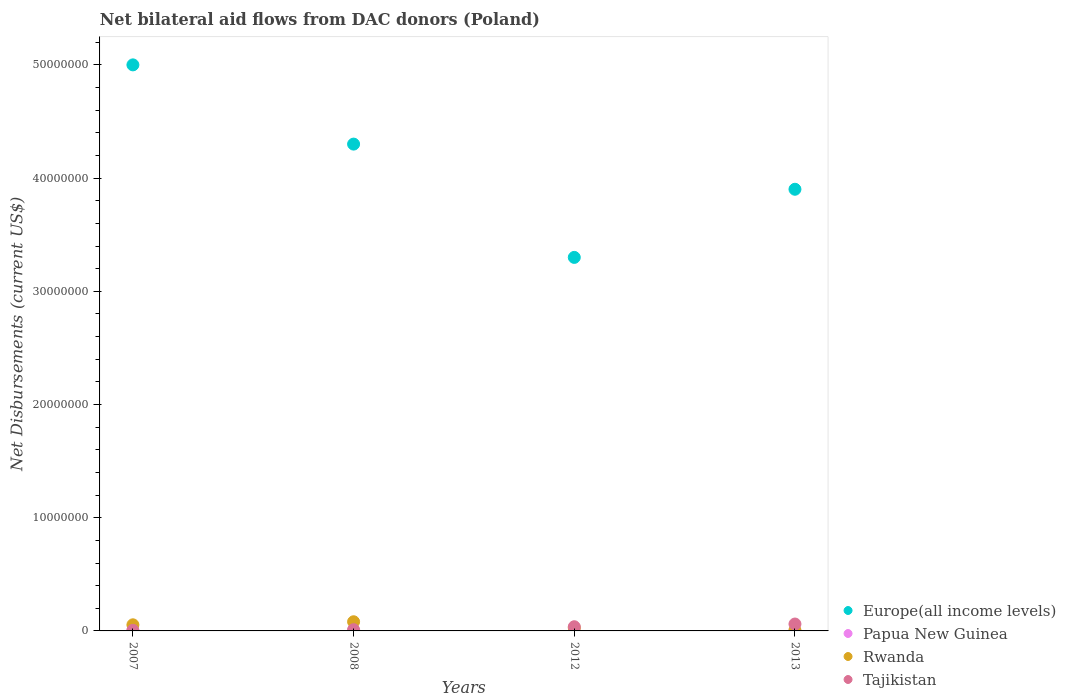How many different coloured dotlines are there?
Provide a succinct answer. 4. Is the number of dotlines equal to the number of legend labels?
Your answer should be compact. Yes. Across all years, what is the maximum net bilateral aid flows in Rwanda?
Provide a short and direct response. 8.10e+05. What is the total net bilateral aid flows in Europe(all income levels) in the graph?
Offer a very short reply. 1.65e+08. What is the average net bilateral aid flows in Papua New Guinea per year?
Give a very brief answer. 2.00e+04. In the year 2007, what is the difference between the net bilateral aid flows in Tajikistan and net bilateral aid flows in Europe(all income levels)?
Keep it short and to the point. -5.00e+07. In how many years, is the net bilateral aid flows in Rwanda greater than 28000000 US$?
Ensure brevity in your answer.  0. What is the ratio of the net bilateral aid flows in Tajikistan in 2008 to that in 2012?
Give a very brief answer. 0.3. Is the net bilateral aid flows in Papua New Guinea in 2008 less than that in 2013?
Offer a very short reply. Yes. What is the difference between the highest and the lowest net bilateral aid flows in Tajikistan?
Ensure brevity in your answer.  5.60e+05. In how many years, is the net bilateral aid flows in Papua New Guinea greater than the average net bilateral aid flows in Papua New Guinea taken over all years?
Your answer should be very brief. 1. Is the sum of the net bilateral aid flows in Rwanda in 2007 and 2013 greater than the maximum net bilateral aid flows in Tajikistan across all years?
Provide a short and direct response. No. Is it the case that in every year, the sum of the net bilateral aid flows in Papua New Guinea and net bilateral aid flows in Rwanda  is greater than the net bilateral aid flows in Europe(all income levels)?
Provide a succinct answer. No. Are the values on the major ticks of Y-axis written in scientific E-notation?
Your answer should be compact. No. Does the graph contain any zero values?
Ensure brevity in your answer.  No. Does the graph contain grids?
Ensure brevity in your answer.  No. What is the title of the graph?
Give a very brief answer. Net bilateral aid flows from DAC donors (Poland). What is the label or title of the X-axis?
Keep it short and to the point. Years. What is the label or title of the Y-axis?
Provide a short and direct response. Net Disbursements (current US$). What is the Net Disbursements (current US$) in Europe(all income levels) in 2007?
Your answer should be very brief. 5.00e+07. What is the Net Disbursements (current US$) of Papua New Guinea in 2007?
Offer a terse response. 3.00e+04. What is the Net Disbursements (current US$) of Rwanda in 2007?
Provide a succinct answer. 5.40e+05. What is the Net Disbursements (current US$) of Europe(all income levels) in 2008?
Provide a short and direct response. 4.30e+07. What is the Net Disbursements (current US$) in Papua New Guinea in 2008?
Provide a succinct answer. 10000. What is the Net Disbursements (current US$) in Rwanda in 2008?
Offer a very short reply. 8.10e+05. What is the Net Disbursements (current US$) of Tajikistan in 2008?
Your response must be concise. 1.10e+05. What is the Net Disbursements (current US$) in Europe(all income levels) in 2012?
Make the answer very short. 3.30e+07. What is the Net Disbursements (current US$) in Papua New Guinea in 2012?
Ensure brevity in your answer.  2.00e+04. What is the Net Disbursements (current US$) of Europe(all income levels) in 2013?
Your answer should be very brief. 3.90e+07. What is the Net Disbursements (current US$) of Rwanda in 2013?
Offer a very short reply. 5.00e+04. What is the Net Disbursements (current US$) of Tajikistan in 2013?
Give a very brief answer. 6.10e+05. Across all years, what is the maximum Net Disbursements (current US$) in Europe(all income levels)?
Provide a short and direct response. 5.00e+07. Across all years, what is the maximum Net Disbursements (current US$) of Rwanda?
Provide a short and direct response. 8.10e+05. Across all years, what is the minimum Net Disbursements (current US$) in Europe(all income levels)?
Ensure brevity in your answer.  3.30e+07. What is the total Net Disbursements (current US$) of Europe(all income levels) in the graph?
Your answer should be compact. 1.65e+08. What is the total Net Disbursements (current US$) in Papua New Guinea in the graph?
Provide a short and direct response. 8.00e+04. What is the total Net Disbursements (current US$) of Rwanda in the graph?
Your answer should be very brief. 1.67e+06. What is the total Net Disbursements (current US$) in Tajikistan in the graph?
Your answer should be very brief. 1.14e+06. What is the difference between the Net Disbursements (current US$) of Europe(all income levels) in 2007 and that in 2012?
Your answer should be very brief. 1.70e+07. What is the difference between the Net Disbursements (current US$) in Papua New Guinea in 2007 and that in 2012?
Give a very brief answer. 10000. What is the difference between the Net Disbursements (current US$) of Tajikistan in 2007 and that in 2012?
Your answer should be compact. -3.20e+05. What is the difference between the Net Disbursements (current US$) in Europe(all income levels) in 2007 and that in 2013?
Offer a terse response. 1.10e+07. What is the difference between the Net Disbursements (current US$) of Tajikistan in 2007 and that in 2013?
Provide a succinct answer. -5.60e+05. What is the difference between the Net Disbursements (current US$) of Europe(all income levels) in 2008 and that in 2012?
Provide a succinct answer. 1.00e+07. What is the difference between the Net Disbursements (current US$) in Rwanda in 2008 and that in 2012?
Keep it short and to the point. 5.40e+05. What is the difference between the Net Disbursements (current US$) in Tajikistan in 2008 and that in 2012?
Give a very brief answer. -2.60e+05. What is the difference between the Net Disbursements (current US$) of Europe(all income levels) in 2008 and that in 2013?
Keep it short and to the point. 3.99e+06. What is the difference between the Net Disbursements (current US$) in Rwanda in 2008 and that in 2013?
Make the answer very short. 7.60e+05. What is the difference between the Net Disbursements (current US$) in Tajikistan in 2008 and that in 2013?
Provide a succinct answer. -5.00e+05. What is the difference between the Net Disbursements (current US$) of Europe(all income levels) in 2012 and that in 2013?
Your answer should be very brief. -6.02e+06. What is the difference between the Net Disbursements (current US$) of Rwanda in 2012 and that in 2013?
Your answer should be very brief. 2.20e+05. What is the difference between the Net Disbursements (current US$) of Europe(all income levels) in 2007 and the Net Disbursements (current US$) of Papua New Guinea in 2008?
Offer a very short reply. 5.00e+07. What is the difference between the Net Disbursements (current US$) in Europe(all income levels) in 2007 and the Net Disbursements (current US$) in Rwanda in 2008?
Your answer should be compact. 4.92e+07. What is the difference between the Net Disbursements (current US$) of Europe(all income levels) in 2007 and the Net Disbursements (current US$) of Tajikistan in 2008?
Ensure brevity in your answer.  4.99e+07. What is the difference between the Net Disbursements (current US$) in Papua New Guinea in 2007 and the Net Disbursements (current US$) in Rwanda in 2008?
Provide a succinct answer. -7.80e+05. What is the difference between the Net Disbursements (current US$) of Papua New Guinea in 2007 and the Net Disbursements (current US$) of Tajikistan in 2008?
Provide a short and direct response. -8.00e+04. What is the difference between the Net Disbursements (current US$) in Europe(all income levels) in 2007 and the Net Disbursements (current US$) in Papua New Guinea in 2012?
Give a very brief answer. 5.00e+07. What is the difference between the Net Disbursements (current US$) in Europe(all income levels) in 2007 and the Net Disbursements (current US$) in Rwanda in 2012?
Provide a succinct answer. 4.97e+07. What is the difference between the Net Disbursements (current US$) of Europe(all income levels) in 2007 and the Net Disbursements (current US$) of Tajikistan in 2012?
Ensure brevity in your answer.  4.96e+07. What is the difference between the Net Disbursements (current US$) of Papua New Guinea in 2007 and the Net Disbursements (current US$) of Tajikistan in 2012?
Make the answer very short. -3.40e+05. What is the difference between the Net Disbursements (current US$) in Rwanda in 2007 and the Net Disbursements (current US$) in Tajikistan in 2012?
Provide a succinct answer. 1.70e+05. What is the difference between the Net Disbursements (current US$) of Europe(all income levels) in 2007 and the Net Disbursements (current US$) of Papua New Guinea in 2013?
Provide a succinct answer. 5.00e+07. What is the difference between the Net Disbursements (current US$) in Europe(all income levels) in 2007 and the Net Disbursements (current US$) in Rwanda in 2013?
Keep it short and to the point. 5.00e+07. What is the difference between the Net Disbursements (current US$) in Europe(all income levels) in 2007 and the Net Disbursements (current US$) in Tajikistan in 2013?
Provide a succinct answer. 4.94e+07. What is the difference between the Net Disbursements (current US$) of Papua New Guinea in 2007 and the Net Disbursements (current US$) of Rwanda in 2013?
Give a very brief answer. -2.00e+04. What is the difference between the Net Disbursements (current US$) in Papua New Guinea in 2007 and the Net Disbursements (current US$) in Tajikistan in 2013?
Provide a short and direct response. -5.80e+05. What is the difference between the Net Disbursements (current US$) of Rwanda in 2007 and the Net Disbursements (current US$) of Tajikistan in 2013?
Your answer should be very brief. -7.00e+04. What is the difference between the Net Disbursements (current US$) of Europe(all income levels) in 2008 and the Net Disbursements (current US$) of Papua New Guinea in 2012?
Ensure brevity in your answer.  4.30e+07. What is the difference between the Net Disbursements (current US$) of Europe(all income levels) in 2008 and the Net Disbursements (current US$) of Rwanda in 2012?
Provide a short and direct response. 4.27e+07. What is the difference between the Net Disbursements (current US$) in Europe(all income levels) in 2008 and the Net Disbursements (current US$) in Tajikistan in 2012?
Offer a terse response. 4.26e+07. What is the difference between the Net Disbursements (current US$) in Papua New Guinea in 2008 and the Net Disbursements (current US$) in Tajikistan in 2012?
Your answer should be very brief. -3.60e+05. What is the difference between the Net Disbursements (current US$) in Rwanda in 2008 and the Net Disbursements (current US$) in Tajikistan in 2012?
Your answer should be compact. 4.40e+05. What is the difference between the Net Disbursements (current US$) of Europe(all income levels) in 2008 and the Net Disbursements (current US$) of Papua New Guinea in 2013?
Keep it short and to the point. 4.30e+07. What is the difference between the Net Disbursements (current US$) in Europe(all income levels) in 2008 and the Net Disbursements (current US$) in Rwanda in 2013?
Offer a terse response. 4.30e+07. What is the difference between the Net Disbursements (current US$) in Europe(all income levels) in 2008 and the Net Disbursements (current US$) in Tajikistan in 2013?
Keep it short and to the point. 4.24e+07. What is the difference between the Net Disbursements (current US$) of Papua New Guinea in 2008 and the Net Disbursements (current US$) of Tajikistan in 2013?
Provide a short and direct response. -6.00e+05. What is the difference between the Net Disbursements (current US$) in Rwanda in 2008 and the Net Disbursements (current US$) in Tajikistan in 2013?
Keep it short and to the point. 2.00e+05. What is the difference between the Net Disbursements (current US$) of Europe(all income levels) in 2012 and the Net Disbursements (current US$) of Papua New Guinea in 2013?
Give a very brief answer. 3.30e+07. What is the difference between the Net Disbursements (current US$) in Europe(all income levels) in 2012 and the Net Disbursements (current US$) in Rwanda in 2013?
Your answer should be compact. 3.30e+07. What is the difference between the Net Disbursements (current US$) in Europe(all income levels) in 2012 and the Net Disbursements (current US$) in Tajikistan in 2013?
Make the answer very short. 3.24e+07. What is the difference between the Net Disbursements (current US$) in Papua New Guinea in 2012 and the Net Disbursements (current US$) in Rwanda in 2013?
Offer a very short reply. -3.00e+04. What is the difference between the Net Disbursements (current US$) in Papua New Guinea in 2012 and the Net Disbursements (current US$) in Tajikistan in 2013?
Give a very brief answer. -5.90e+05. What is the difference between the Net Disbursements (current US$) of Rwanda in 2012 and the Net Disbursements (current US$) of Tajikistan in 2013?
Provide a succinct answer. -3.40e+05. What is the average Net Disbursements (current US$) of Europe(all income levels) per year?
Offer a very short reply. 4.13e+07. What is the average Net Disbursements (current US$) in Rwanda per year?
Ensure brevity in your answer.  4.18e+05. What is the average Net Disbursements (current US$) of Tajikistan per year?
Your answer should be compact. 2.85e+05. In the year 2007, what is the difference between the Net Disbursements (current US$) of Europe(all income levels) and Net Disbursements (current US$) of Papua New Guinea?
Make the answer very short. 5.00e+07. In the year 2007, what is the difference between the Net Disbursements (current US$) in Europe(all income levels) and Net Disbursements (current US$) in Rwanda?
Make the answer very short. 4.95e+07. In the year 2007, what is the difference between the Net Disbursements (current US$) of Europe(all income levels) and Net Disbursements (current US$) of Tajikistan?
Give a very brief answer. 5.00e+07. In the year 2007, what is the difference between the Net Disbursements (current US$) of Papua New Guinea and Net Disbursements (current US$) of Rwanda?
Your answer should be compact. -5.10e+05. In the year 2007, what is the difference between the Net Disbursements (current US$) in Papua New Guinea and Net Disbursements (current US$) in Tajikistan?
Give a very brief answer. -2.00e+04. In the year 2008, what is the difference between the Net Disbursements (current US$) of Europe(all income levels) and Net Disbursements (current US$) of Papua New Guinea?
Provide a succinct answer. 4.30e+07. In the year 2008, what is the difference between the Net Disbursements (current US$) of Europe(all income levels) and Net Disbursements (current US$) of Rwanda?
Your response must be concise. 4.22e+07. In the year 2008, what is the difference between the Net Disbursements (current US$) in Europe(all income levels) and Net Disbursements (current US$) in Tajikistan?
Give a very brief answer. 4.29e+07. In the year 2008, what is the difference between the Net Disbursements (current US$) in Papua New Guinea and Net Disbursements (current US$) in Rwanda?
Ensure brevity in your answer.  -8.00e+05. In the year 2012, what is the difference between the Net Disbursements (current US$) in Europe(all income levels) and Net Disbursements (current US$) in Papua New Guinea?
Your response must be concise. 3.30e+07. In the year 2012, what is the difference between the Net Disbursements (current US$) in Europe(all income levels) and Net Disbursements (current US$) in Rwanda?
Your answer should be compact. 3.27e+07. In the year 2012, what is the difference between the Net Disbursements (current US$) in Europe(all income levels) and Net Disbursements (current US$) in Tajikistan?
Provide a succinct answer. 3.26e+07. In the year 2012, what is the difference between the Net Disbursements (current US$) in Papua New Guinea and Net Disbursements (current US$) in Rwanda?
Offer a very short reply. -2.50e+05. In the year 2012, what is the difference between the Net Disbursements (current US$) in Papua New Guinea and Net Disbursements (current US$) in Tajikistan?
Offer a terse response. -3.50e+05. In the year 2012, what is the difference between the Net Disbursements (current US$) of Rwanda and Net Disbursements (current US$) of Tajikistan?
Offer a terse response. -1.00e+05. In the year 2013, what is the difference between the Net Disbursements (current US$) in Europe(all income levels) and Net Disbursements (current US$) in Papua New Guinea?
Provide a short and direct response. 3.90e+07. In the year 2013, what is the difference between the Net Disbursements (current US$) in Europe(all income levels) and Net Disbursements (current US$) in Rwanda?
Your answer should be compact. 3.90e+07. In the year 2013, what is the difference between the Net Disbursements (current US$) of Europe(all income levels) and Net Disbursements (current US$) of Tajikistan?
Keep it short and to the point. 3.84e+07. In the year 2013, what is the difference between the Net Disbursements (current US$) of Papua New Guinea and Net Disbursements (current US$) of Tajikistan?
Offer a terse response. -5.90e+05. In the year 2013, what is the difference between the Net Disbursements (current US$) in Rwanda and Net Disbursements (current US$) in Tajikistan?
Offer a terse response. -5.60e+05. What is the ratio of the Net Disbursements (current US$) of Europe(all income levels) in 2007 to that in 2008?
Give a very brief answer. 1.16. What is the ratio of the Net Disbursements (current US$) of Papua New Guinea in 2007 to that in 2008?
Offer a terse response. 3. What is the ratio of the Net Disbursements (current US$) of Tajikistan in 2007 to that in 2008?
Keep it short and to the point. 0.45. What is the ratio of the Net Disbursements (current US$) in Europe(all income levels) in 2007 to that in 2012?
Provide a short and direct response. 1.52. What is the ratio of the Net Disbursements (current US$) of Papua New Guinea in 2007 to that in 2012?
Give a very brief answer. 1.5. What is the ratio of the Net Disbursements (current US$) in Tajikistan in 2007 to that in 2012?
Ensure brevity in your answer.  0.14. What is the ratio of the Net Disbursements (current US$) in Europe(all income levels) in 2007 to that in 2013?
Your response must be concise. 1.28. What is the ratio of the Net Disbursements (current US$) in Tajikistan in 2007 to that in 2013?
Your answer should be compact. 0.08. What is the ratio of the Net Disbursements (current US$) of Europe(all income levels) in 2008 to that in 2012?
Give a very brief answer. 1.3. What is the ratio of the Net Disbursements (current US$) in Papua New Guinea in 2008 to that in 2012?
Offer a very short reply. 0.5. What is the ratio of the Net Disbursements (current US$) in Rwanda in 2008 to that in 2012?
Provide a succinct answer. 3. What is the ratio of the Net Disbursements (current US$) of Tajikistan in 2008 to that in 2012?
Your response must be concise. 0.3. What is the ratio of the Net Disbursements (current US$) in Europe(all income levels) in 2008 to that in 2013?
Offer a terse response. 1.1. What is the ratio of the Net Disbursements (current US$) in Papua New Guinea in 2008 to that in 2013?
Provide a short and direct response. 0.5. What is the ratio of the Net Disbursements (current US$) of Rwanda in 2008 to that in 2013?
Provide a short and direct response. 16.2. What is the ratio of the Net Disbursements (current US$) of Tajikistan in 2008 to that in 2013?
Give a very brief answer. 0.18. What is the ratio of the Net Disbursements (current US$) in Europe(all income levels) in 2012 to that in 2013?
Provide a short and direct response. 0.85. What is the ratio of the Net Disbursements (current US$) in Papua New Guinea in 2012 to that in 2013?
Your answer should be compact. 1. What is the ratio of the Net Disbursements (current US$) in Rwanda in 2012 to that in 2013?
Provide a short and direct response. 5.4. What is the ratio of the Net Disbursements (current US$) in Tajikistan in 2012 to that in 2013?
Your response must be concise. 0.61. What is the difference between the highest and the second highest Net Disbursements (current US$) of Europe(all income levels)?
Keep it short and to the point. 7.00e+06. What is the difference between the highest and the second highest Net Disbursements (current US$) of Papua New Guinea?
Provide a succinct answer. 10000. What is the difference between the highest and the lowest Net Disbursements (current US$) in Europe(all income levels)?
Provide a short and direct response. 1.70e+07. What is the difference between the highest and the lowest Net Disbursements (current US$) of Papua New Guinea?
Provide a succinct answer. 2.00e+04. What is the difference between the highest and the lowest Net Disbursements (current US$) of Rwanda?
Offer a very short reply. 7.60e+05. What is the difference between the highest and the lowest Net Disbursements (current US$) of Tajikistan?
Make the answer very short. 5.60e+05. 